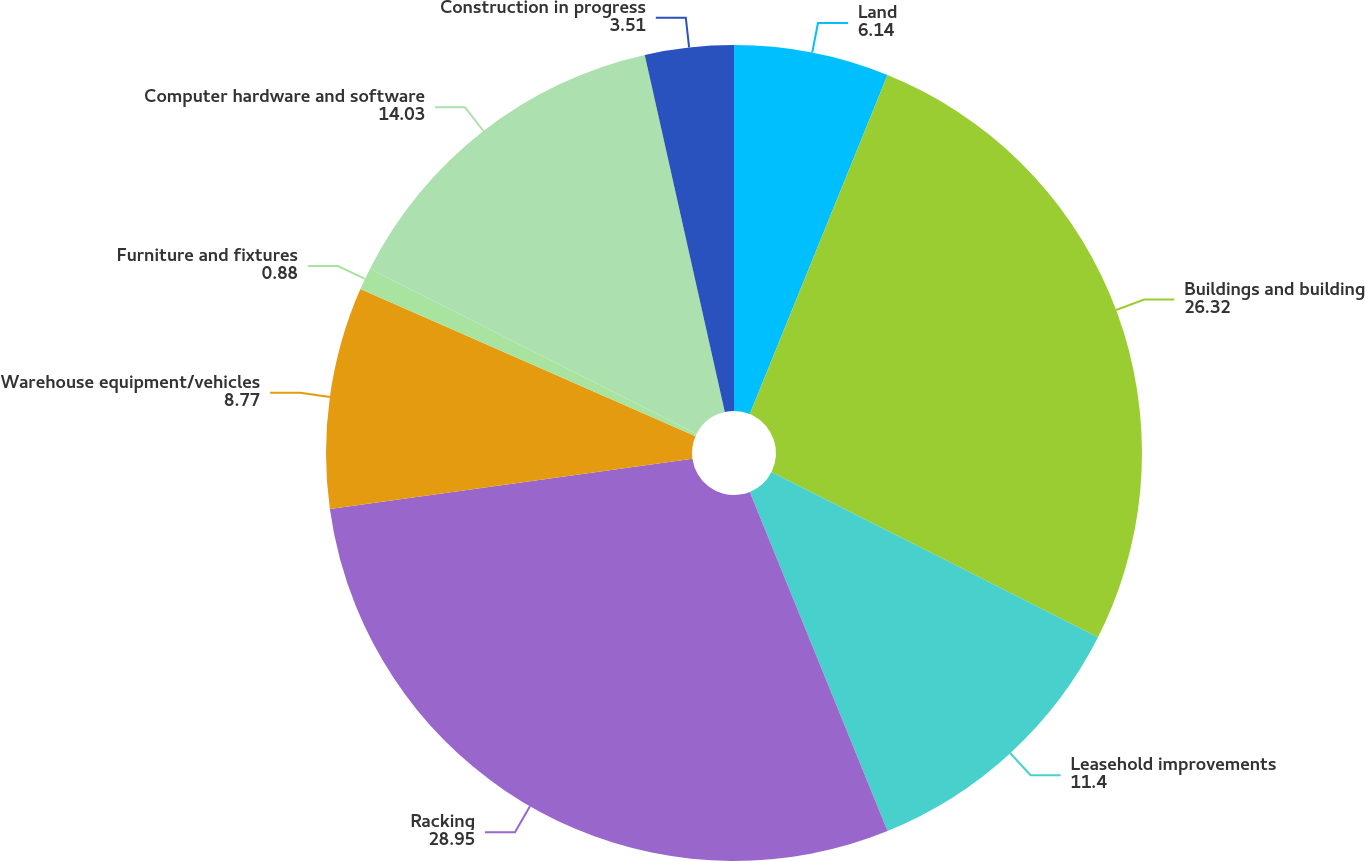Convert chart. <chart><loc_0><loc_0><loc_500><loc_500><pie_chart><fcel>Land<fcel>Buildings and building<fcel>Leasehold improvements<fcel>Racking<fcel>Warehouse equipment/vehicles<fcel>Furniture and fixtures<fcel>Computer hardware and software<fcel>Construction in progress<nl><fcel>6.14%<fcel>26.32%<fcel>11.4%<fcel>28.95%<fcel>8.77%<fcel>0.88%<fcel>14.03%<fcel>3.51%<nl></chart> 